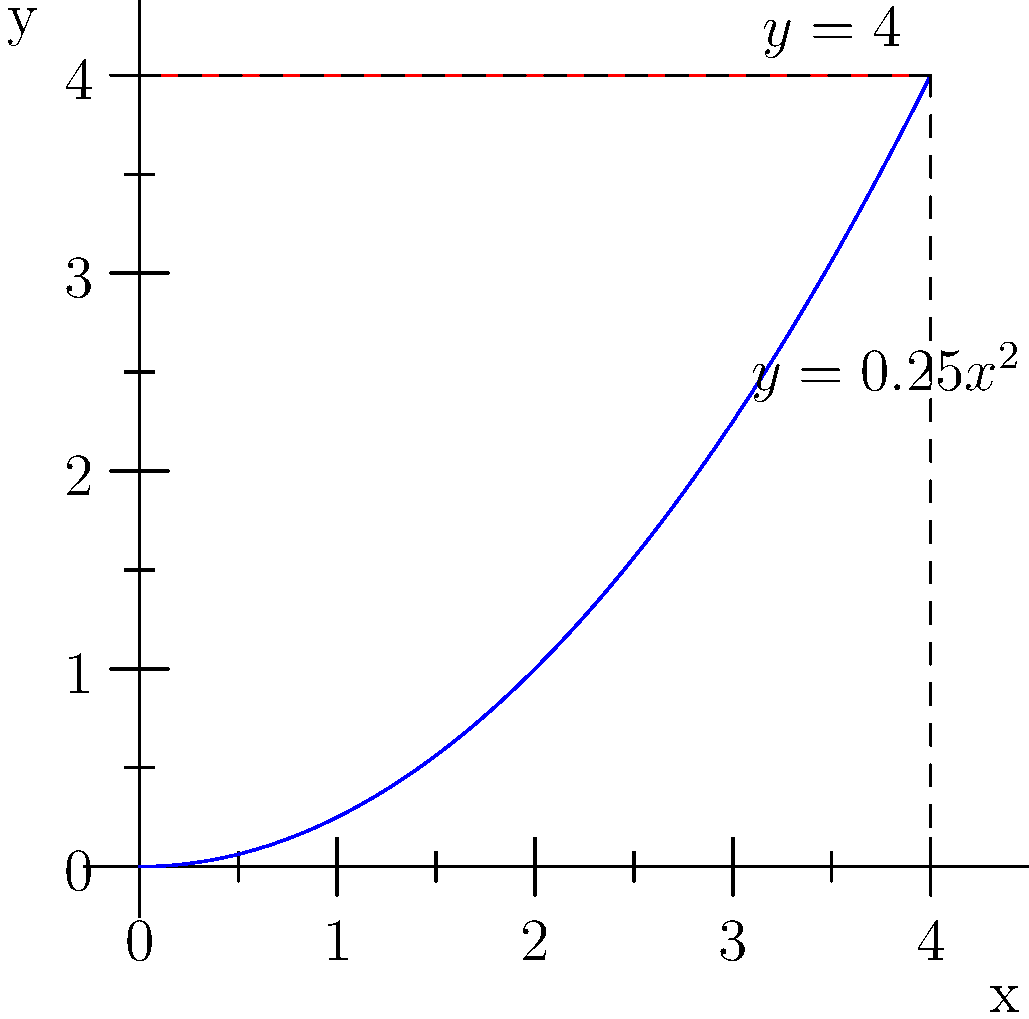A sports trophy has a shape formed by rotating the region bounded by $y=0.25x^2$, $y=4$, and the y-axis about the y-axis. Calculate the volume of this trophy using the method of cylindrical shells. To solve this problem using the method of cylindrical shells, we'll follow these steps:

1) The volume formula using cylindrical shells is:
   $$V = 2\pi \int_a^b x[f(x) - g(x)] dx$$
   where $f(x)$ is the outer function and $g(x)$ is the inner function.

2) In this case:
   $f(x) = 4$ (outer function)
   $g(x) = 0.25x^2$ (inner function)
   $a = 0$ and $b = 4$ (limits of integration)

3) Substituting into the formula:
   $$V = 2\pi \int_0^4 x[4 - 0.25x^2] dx$$

4) Simplify the integrand:
   $$V = 2\pi \int_0^4 (4x - 0.25x^3) dx$$

5) Integrate:
   $$V = 2\pi \left[2x^2 - \frac{1}{16}x^4\right]_0^4$$

6) Evaluate the definite integral:
   $$V = 2\pi \left[(2(4^2) - \frac{1}{16}(4^4)) - (2(0^2) - \frac{1}{16}(0^4))\right]$$
   $$V = 2\pi \left[32 - 16 - 0\right]$$
   $$V = 2\pi (16)$$
   $$V = 32\pi$$

Therefore, the volume of the trophy is $32\pi$ cubic units.
Answer: $32\pi$ cubic units 